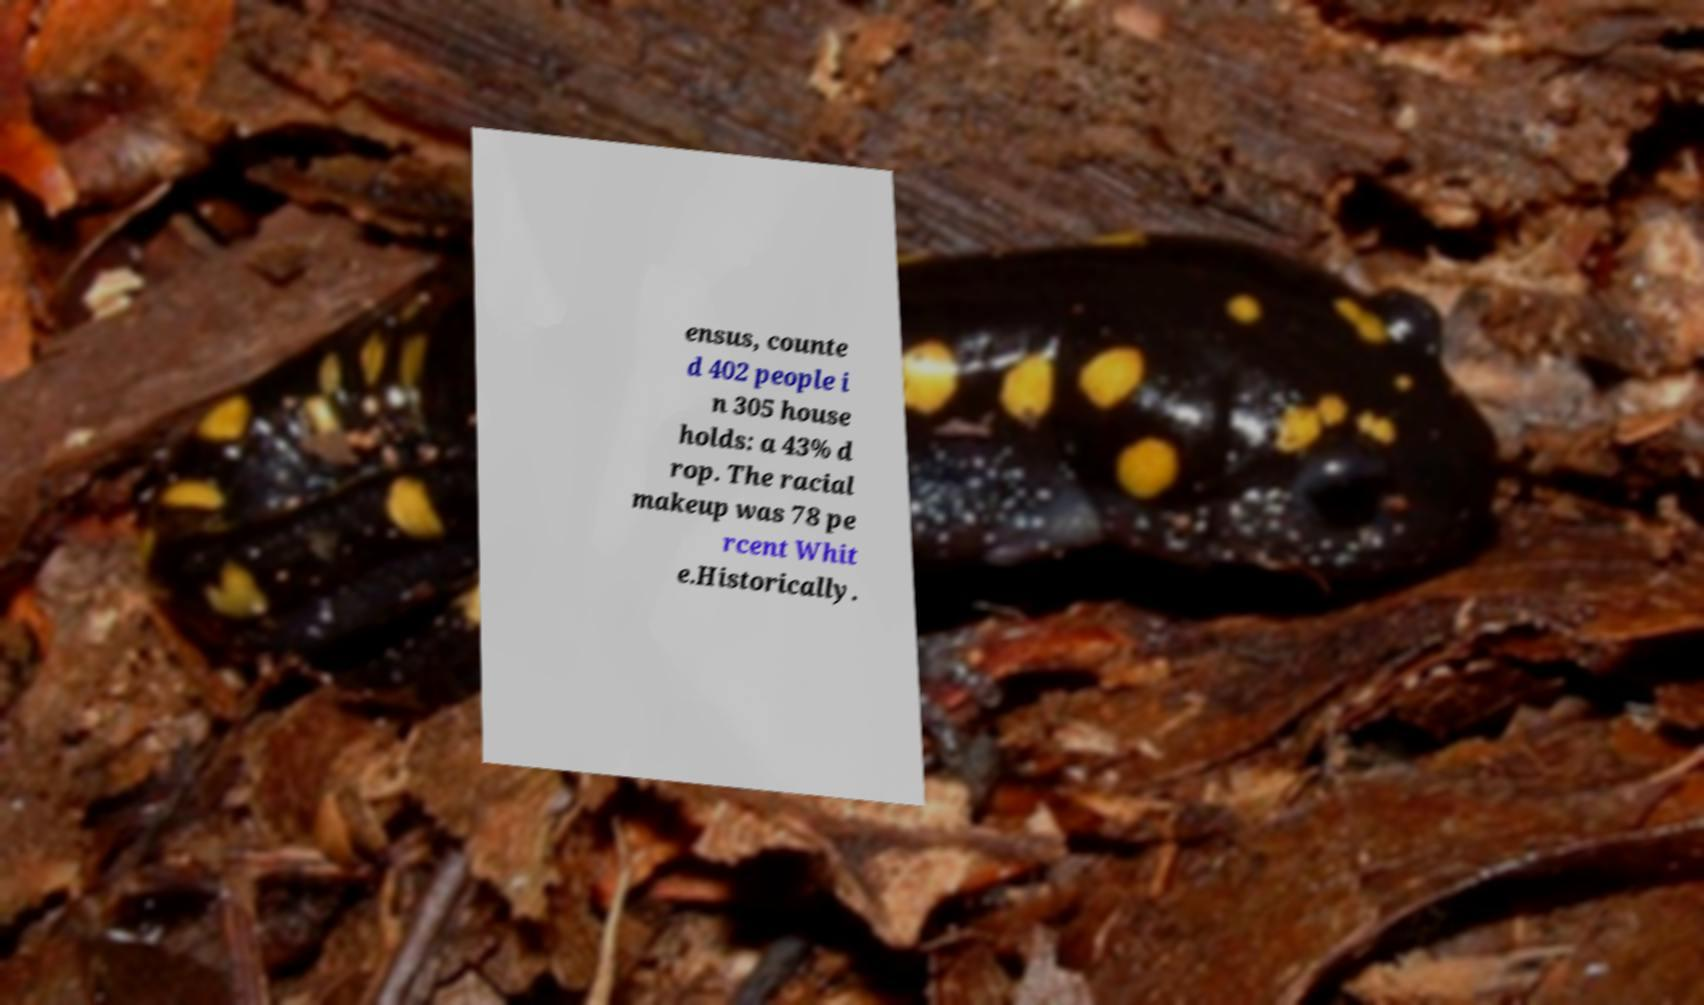Can you accurately transcribe the text from the provided image for me? ensus, counte d 402 people i n 305 house holds: a 43% d rop. The racial makeup was 78 pe rcent Whit e.Historically. 